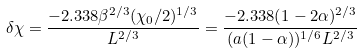Convert formula to latex. <formula><loc_0><loc_0><loc_500><loc_500>\delta { \chi } = \frac { - 2 . 3 3 8 \beta ^ { 2 / 3 } ( \chi _ { 0 } / 2 ) ^ { 1 / 3 } } { L ^ { 2 / 3 } } = \frac { - 2 . 3 3 8 ( 1 - 2 \alpha ) ^ { 2 / 3 } } { ( a ( 1 - \alpha ) ) ^ { 1 / 6 } L ^ { 2 / 3 } }</formula> 